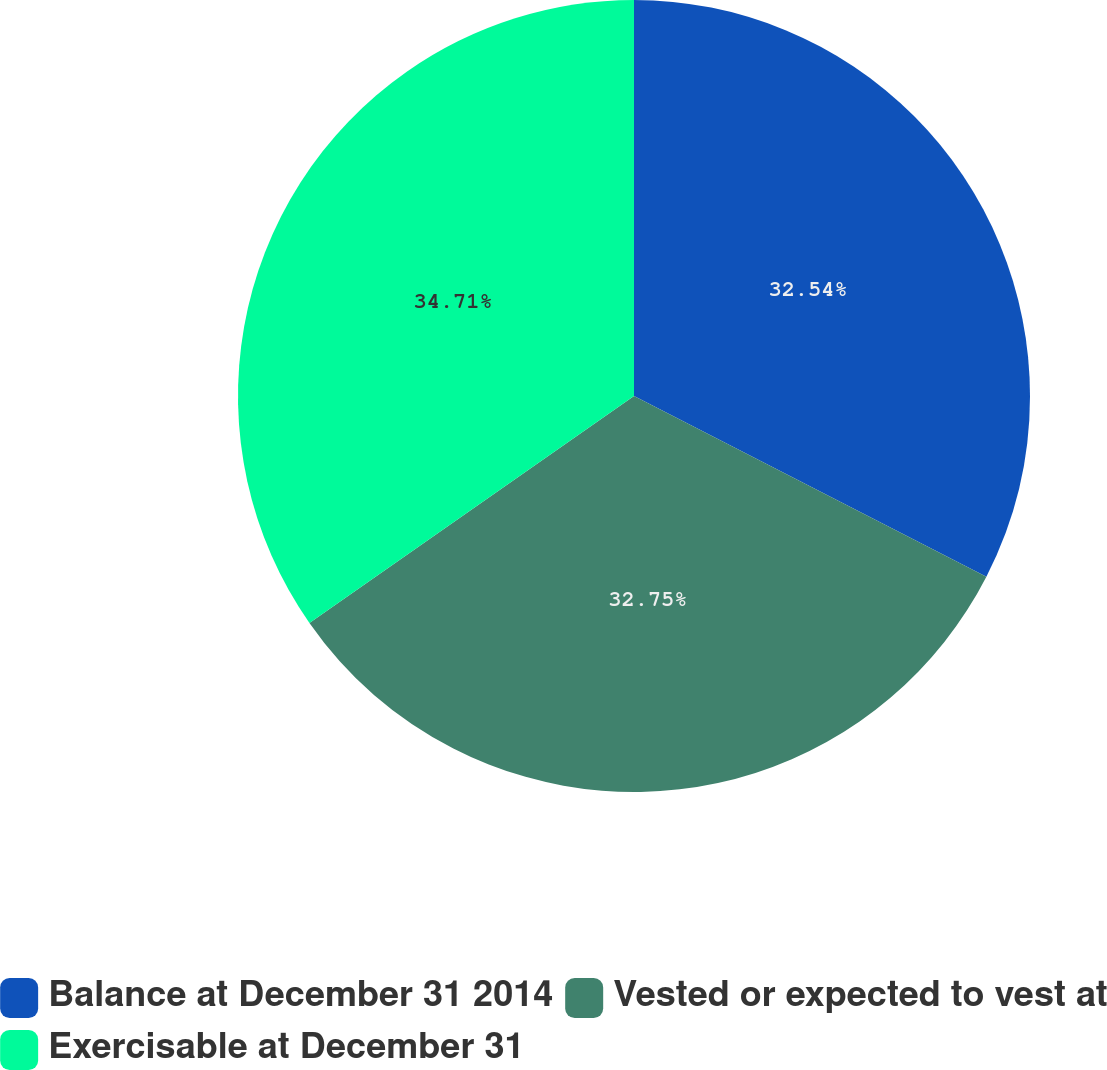Convert chart. <chart><loc_0><loc_0><loc_500><loc_500><pie_chart><fcel>Balance at December 31 2014<fcel>Vested or expected to vest at<fcel>Exercisable at December 31<nl><fcel>32.54%<fcel>32.75%<fcel>34.71%<nl></chart> 